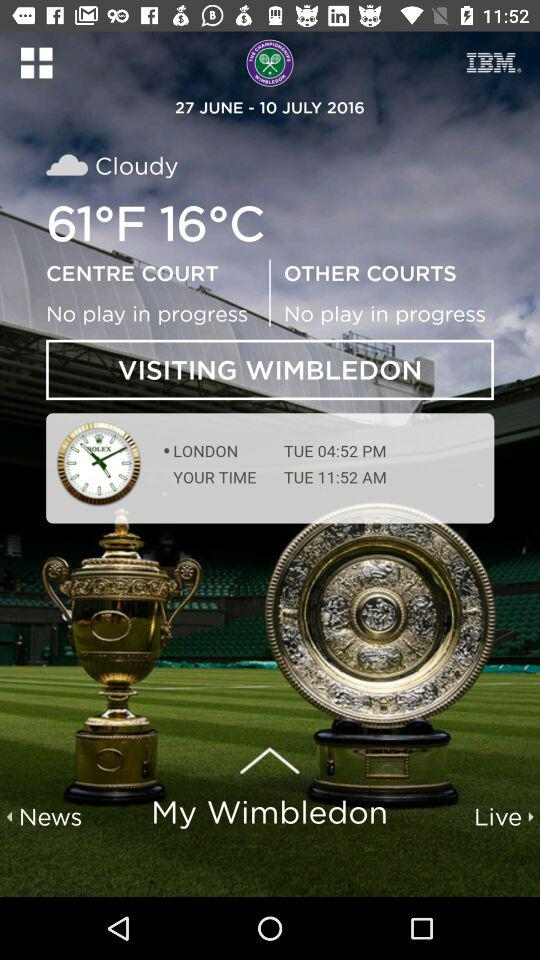How many courts are not showing any play in progress?
Answer the question using a single word or phrase. 2 